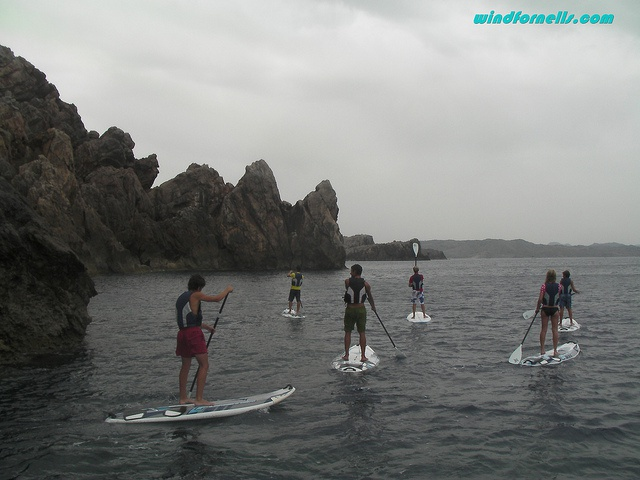Describe the objects in this image and their specific colors. I can see people in lightgray, black, maroon, and gray tones, surfboard in lightgray, gray, darkgray, black, and purple tones, people in lightgray, black, gray, and darkgray tones, people in lightgray, black, maroon, and gray tones, and surfboard in lightgray, darkgray, gray, and black tones in this image. 